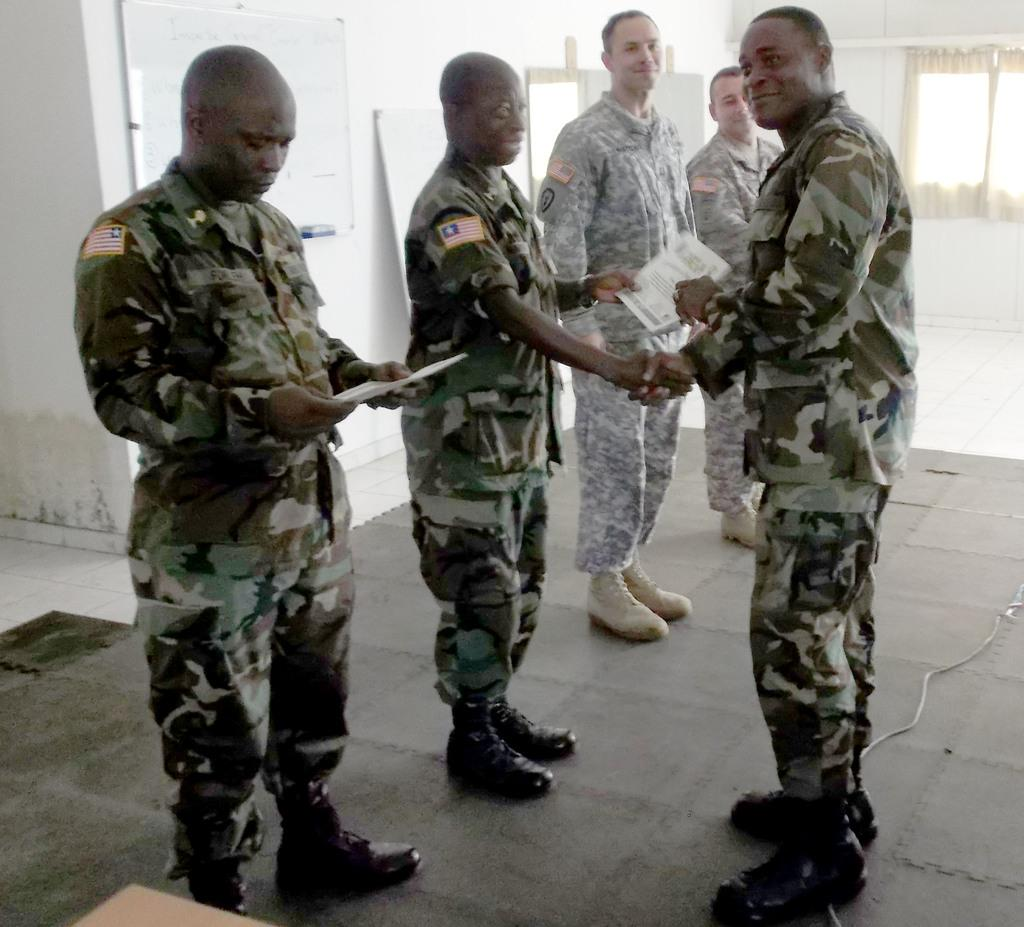How many men are present in the image? There are five men standing in the image. What type of clothing are the men wearing? The men are wearing army clothes. What type of footwear are the men wearing? The men are wearing shoes. What is the purpose of the paper in the image? The presence of the paper in the image is not clear, but it might be used for note-taking or documentation. What is the cable wire used for in the image? The purpose of the cable wire in the image is not clear, but it might be used for communication or power. What type of floor is visible in the image? The floor visible in the image is not described, but it could be a hard surface like tile or wood. What is the purpose of the window in the image? The window in the image provides natural light and a view of the outside. What is the function of the curtains associated with the window? The curtains associated with the window can be used for privacy or to control the amount of light entering the room. What is the purpose of the whiteboard in the image? The whiteboard in the image can be used for writing, drawing, or displaying information. How many celery sticks are visible on the whiteboard in the image? There are no celery sticks visible on the whiteboard in the image. How many chairs are present in the image? The provided facts do not mention chairs, so we cannot determine the number of chairs in the image. 